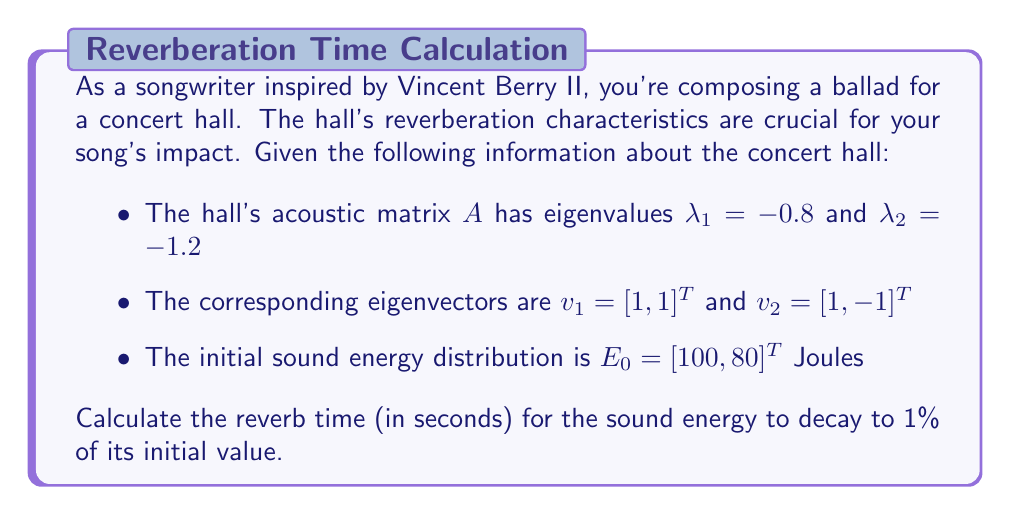Give your solution to this math problem. Let's approach this step-by-step:

1) The sound energy decay in a room can be modeled by the differential equation:

   $$\frac{dE}{dt} = AE$$

   where $E$ is the energy vector and $A$ is the acoustic matrix.

2) The solution to this equation is of the form:

   $$E(t) = c_1e^{\lambda_1t}v_1 + c_2e^{\lambda_2t}v_2$$

   where $c_1$ and $c_2$ are constants we need to determine.

3) At $t=0$, we have:

   $$E_0 = c_1v_1 + c_2v_2$$

4) We can solve this system of equations:

   $$\begin{bmatrix} 100 \\ 80 \end{bmatrix} = c_1\begin{bmatrix} 1 \\ 1 \end{bmatrix} + c_2\begin{bmatrix} 1 \\ -1 \end{bmatrix}$$

   This gives us $c_1 = 90$ and $c_2 = 10$.

5) Now our solution is:

   $$E(t) = 90e^{-0.8t}\begin{bmatrix} 1 \\ 1 \end{bmatrix} + 10e^{-1.2t}\begin{bmatrix} 1 \\ -1 \end{bmatrix}$$

6) The total energy at time $t$ is the sum of the components:

   $$E_{total}(t) = 90e^{-0.8t} + 90e^{-0.8t} + 10e^{-1.2t} - 10e^{-1.2t} = 180e^{-0.8t}$$

7) The reverb time $T$ is when the energy decays to 1% of its initial value:

   $$180e^{-0.8T} = 0.01 \cdot 180$$

8) Solving for $T$:

   $$e^{-0.8T} = 0.01$$
   $$-0.8T = \ln(0.01)$$
   $$T = -\frac{\ln(0.01)}{0.8} \approx 5.76 \text{ seconds}$$
Answer: The reverb time for the sound energy to decay to 1% of its initial value is approximately 5.76 seconds. 